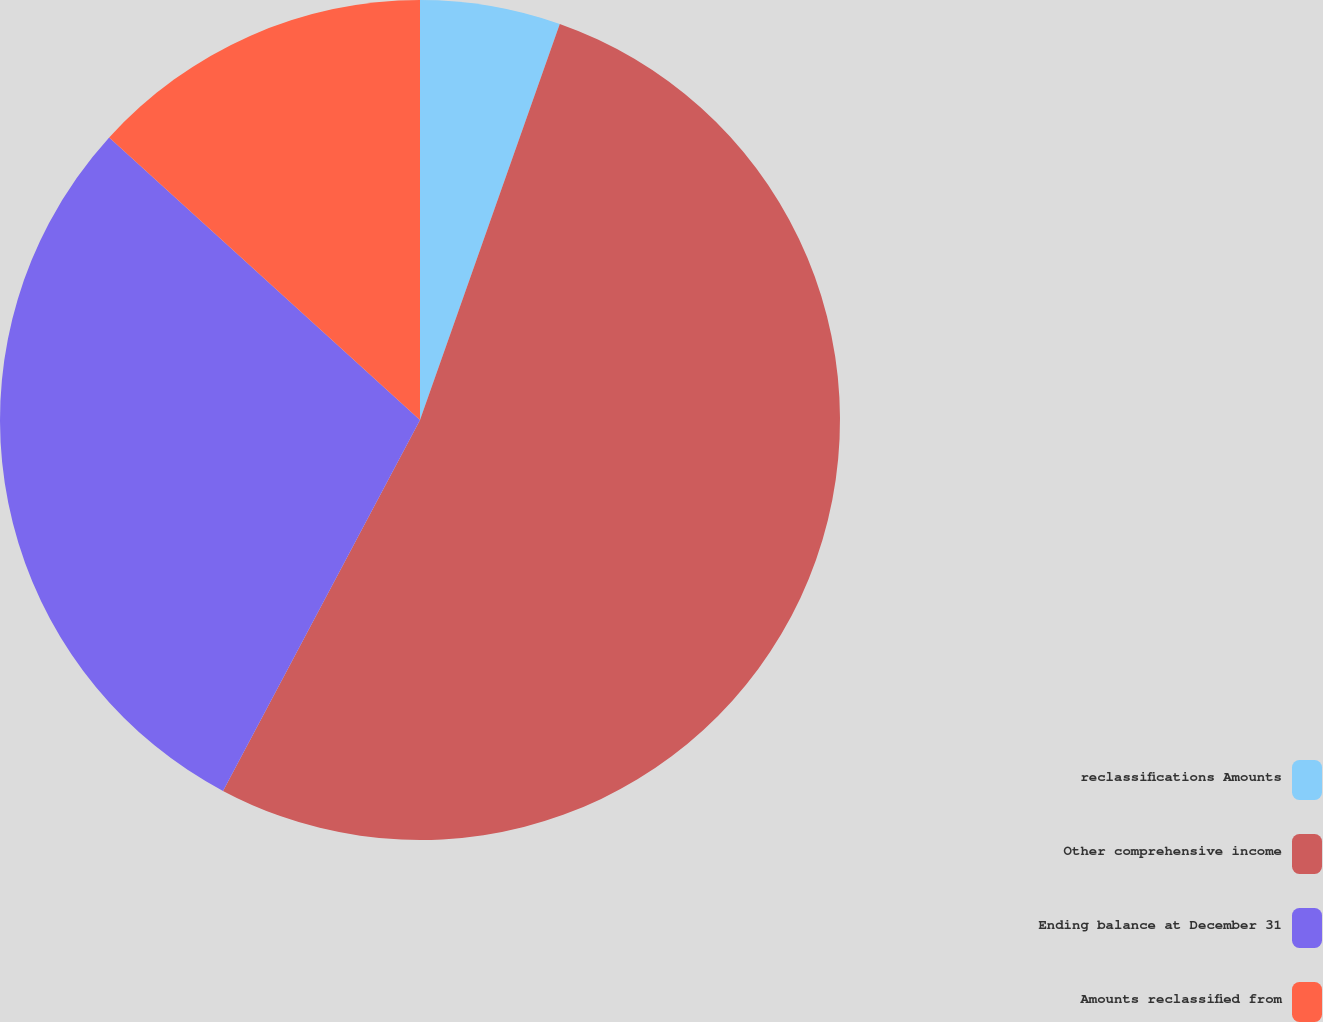Convert chart. <chart><loc_0><loc_0><loc_500><loc_500><pie_chart><fcel>reclassifications Amounts<fcel>Other comprehensive income<fcel>Ending balance at December 31<fcel>Amounts reclassified from<nl><fcel>5.4%<fcel>52.37%<fcel>28.97%<fcel>13.26%<nl></chart> 